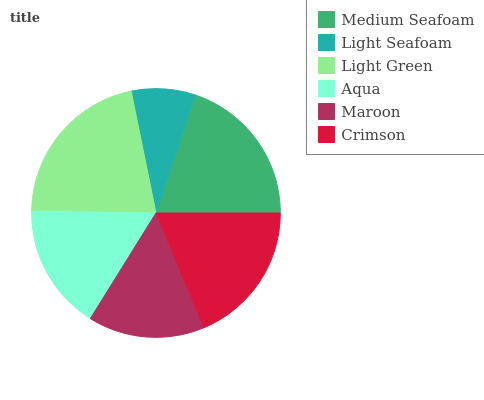Is Light Seafoam the minimum?
Answer yes or no. Yes. Is Light Green the maximum?
Answer yes or no. Yes. Is Light Green the minimum?
Answer yes or no. No. Is Light Seafoam the maximum?
Answer yes or no. No. Is Light Green greater than Light Seafoam?
Answer yes or no. Yes. Is Light Seafoam less than Light Green?
Answer yes or no. Yes. Is Light Seafoam greater than Light Green?
Answer yes or no. No. Is Light Green less than Light Seafoam?
Answer yes or no. No. Is Crimson the high median?
Answer yes or no. Yes. Is Aqua the low median?
Answer yes or no. Yes. Is Light Seafoam the high median?
Answer yes or no. No. Is Light Green the low median?
Answer yes or no. No. 